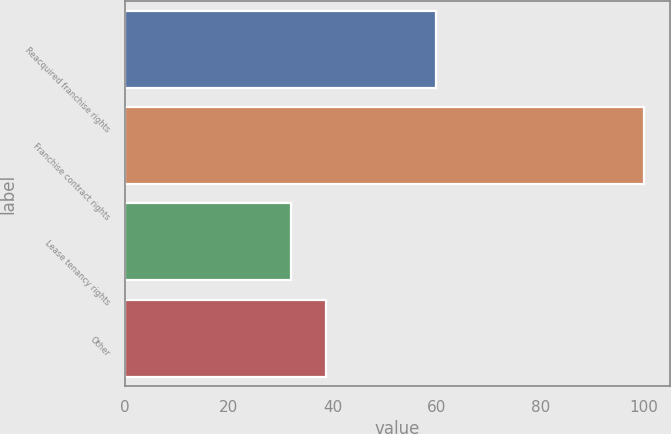Convert chart. <chart><loc_0><loc_0><loc_500><loc_500><bar_chart><fcel>Reacquired franchise rights<fcel>Franchise contract rights<fcel>Lease tenancy rights<fcel>Other<nl><fcel>60<fcel>100<fcel>32<fcel>38.8<nl></chart> 